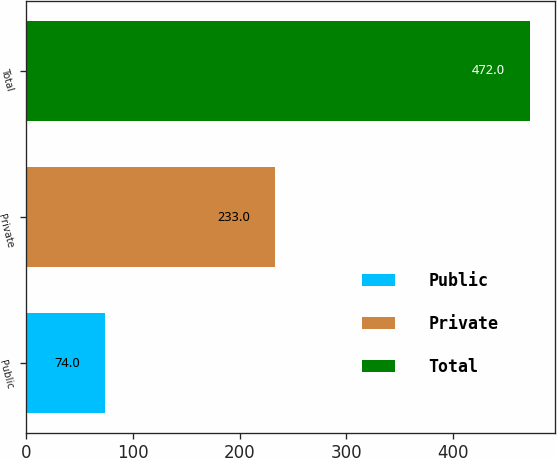<chart> <loc_0><loc_0><loc_500><loc_500><bar_chart><fcel>Public<fcel>Private<fcel>Total<nl><fcel>74<fcel>233<fcel>472<nl></chart> 